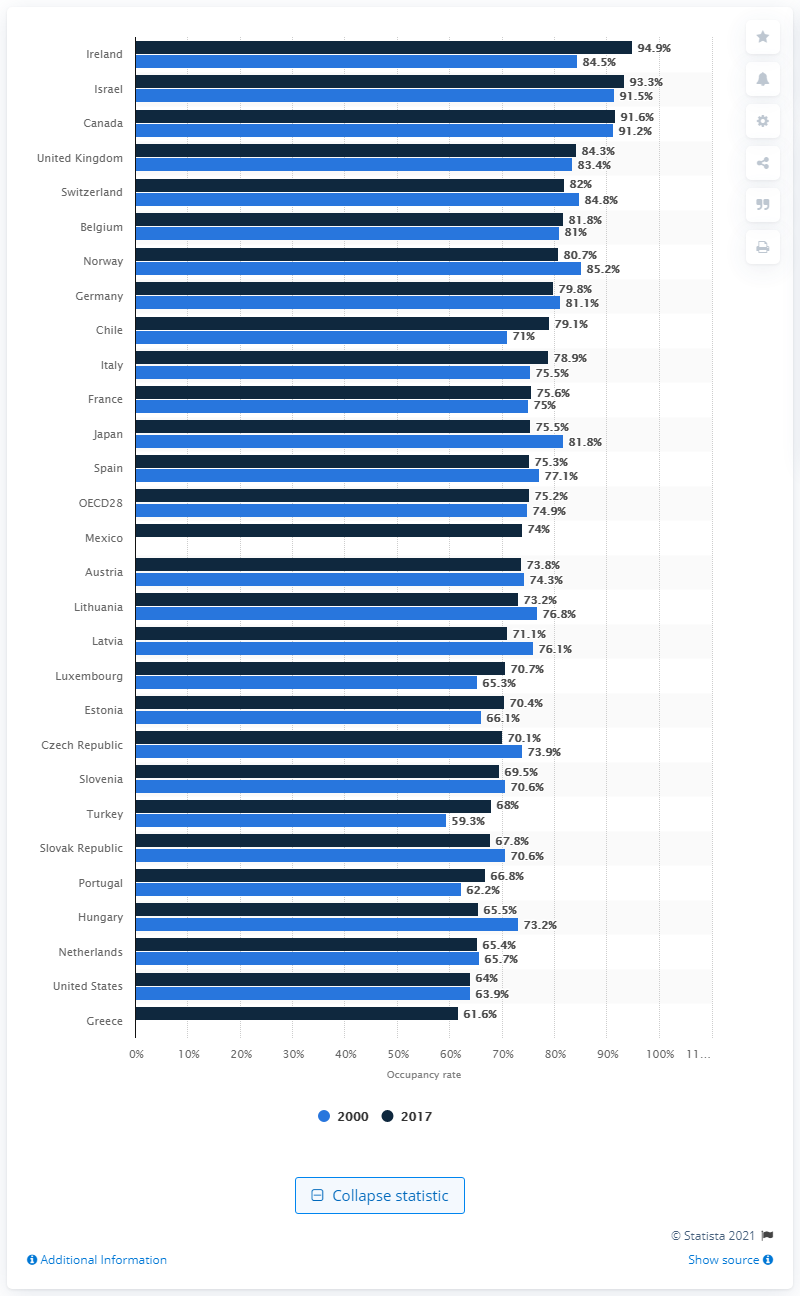Outline some significant characteristics in this image. The occupancy rate of acute care beds in Ireland in 2017 was 94.9%. In 2000, the acute care bed occupancy rate in Ireland was 84.5%. 